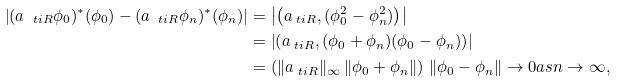Convert formula to latex. <formula><loc_0><loc_0><loc_500><loc_500>\left | ( a _ { \ t i R } \phi _ { 0 } ) ^ { * } ( \phi _ { 0 } ) - ( a _ { \ t i R } \phi _ { n } ) ^ { * } ( \phi _ { n } ) \right | & = \left | \left ( a _ { \ t i R } , ( \phi _ { 0 } ^ { 2 } - \phi _ { n } ^ { 2 } ) \right ) \right | \\ & = \left | \left ( a _ { \ t i R } , ( \phi _ { 0 } + \phi _ { n } ) ( \phi _ { 0 } - \phi _ { n } ) \right ) \right | \\ & = \left ( \| a _ { \ t i R } \| _ { \infty } \, \| \phi _ { 0 } + \phi _ { n } \| \right ) \, \| \phi _ { 0 } - \phi _ { n } \| \to 0 a s n \to \infty ,</formula> 